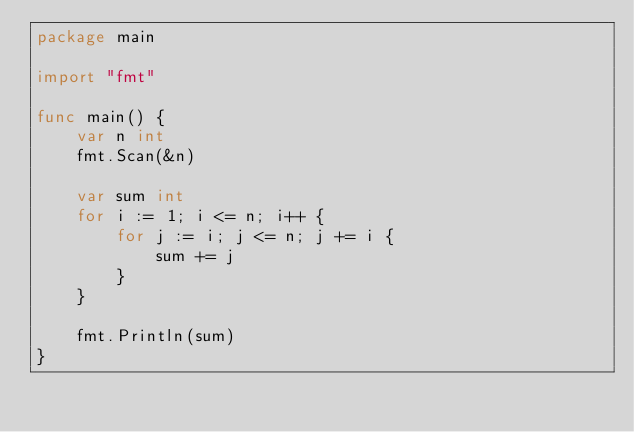<code> <loc_0><loc_0><loc_500><loc_500><_Go_>package main

import "fmt"

func main() {
	var n int
	fmt.Scan(&n)

	var sum int
	for i := 1; i <= n; i++ {
		for j := i; j <= n; j += i {
			sum += j
		}
	}

	fmt.Println(sum)
}
</code> 